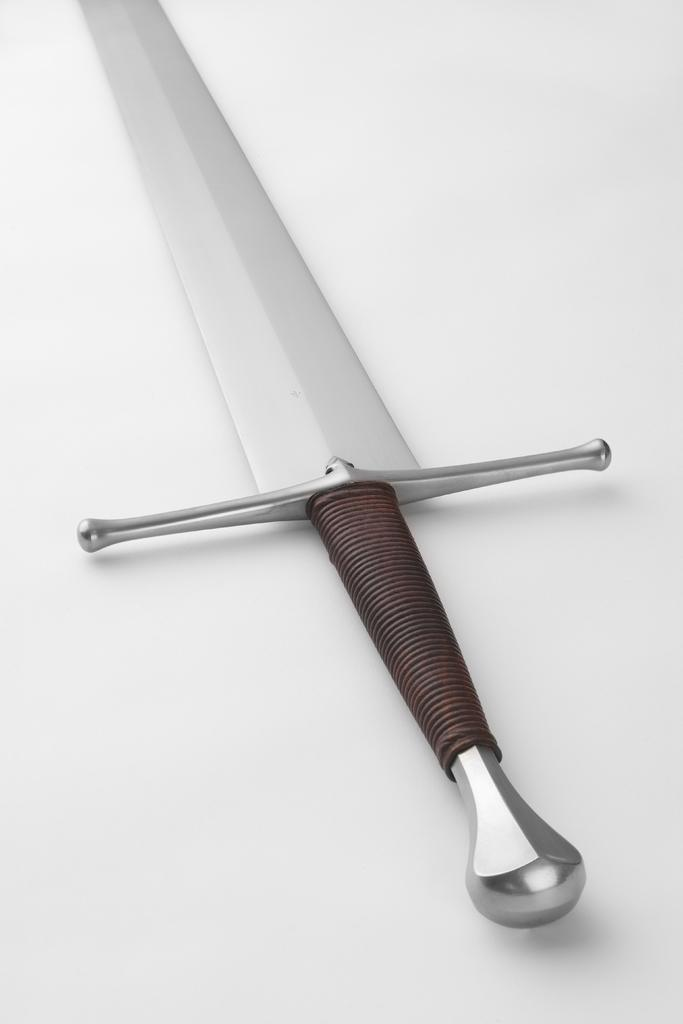What object can be seen in the image? There is a sword in the image. What color is the background of the image? The background of the image is white. What type of cream is being used to polish the sword in the image? There is no cream present in the image, and the sword does not appear to be polished. 